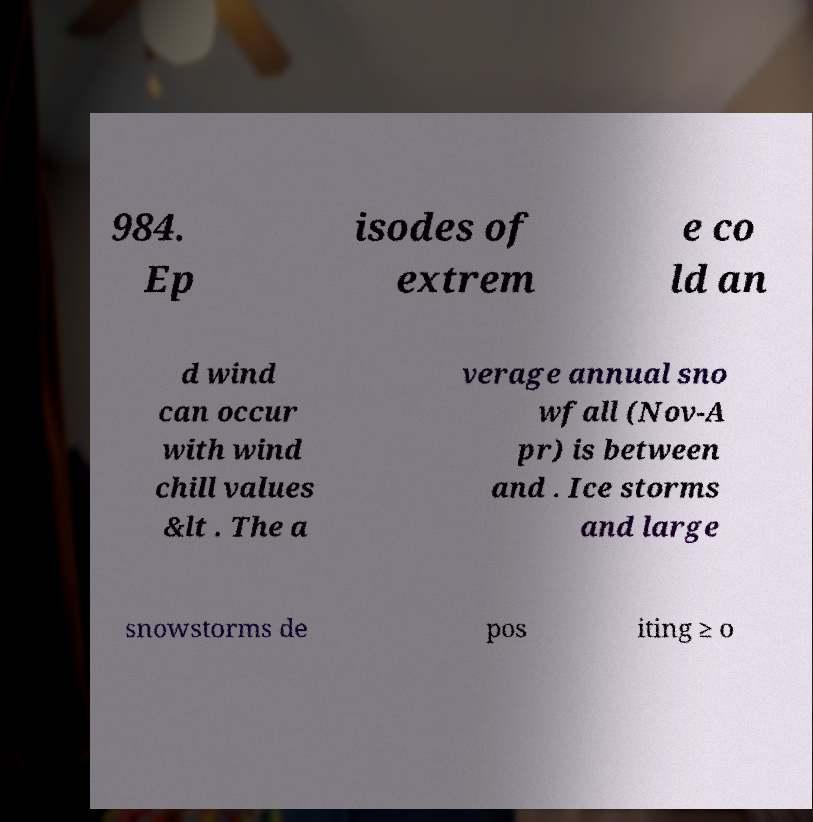Please read and relay the text visible in this image. What does it say? 984. Ep isodes of extrem e co ld an d wind can occur with wind chill values &lt . The a verage annual sno wfall (Nov-A pr) is between and . Ice storms and large snowstorms de pos iting ≥ o 